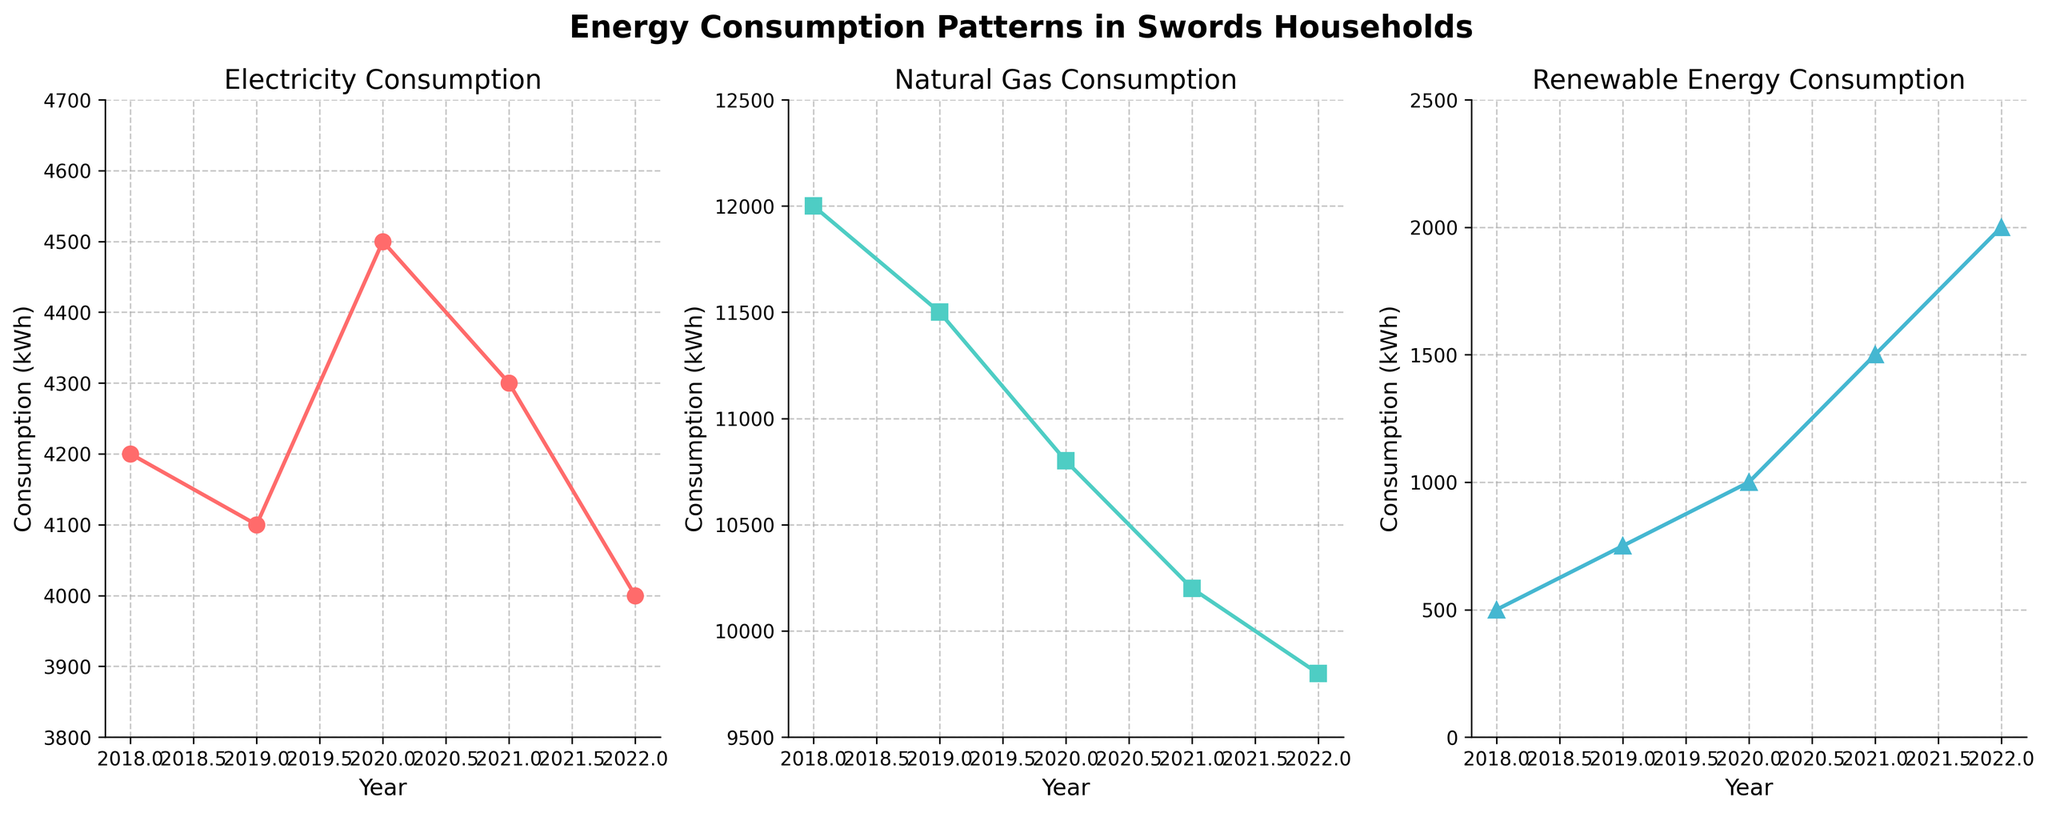What is the title of the figure? The title of the figure is written at the top, centrally aligned, in bold and larger font size.
Answer: Energy Consumption Patterns in Swords Households How many years of data are shown in the plots? The x-axis of each subplot lists the years for which data is provided. By counting the number of years listed, the total number is determined.
Answer: 5 In which year was the electricity consumption highest? The plot for 'Electricity Consumption' shows a peak in the curve. The y-axis value corresponding to the peak is read against the year on the x-axis.
Answer: 2020 What is the trend of renewable energy consumption from 2018 to 2022? The plot for 'Renewable Energy Consumption' shows a clear upward trend. Observing the points from left to right, the values increase each year.
Answer: Increasing How much did natural gas consumption decrease from 2018 to 2022? The 'Natural Gas Consumption' plot shows the values for 2018 and 2022. Subtract the 2022 value from the 2018 value to find the decrease.
Answer: 2200 kWh Which energy source experienced the most significant decrease from 2018 to 2022? By comparing the values for each energy source in 2018 and 2022 across all three plots, calculate the decrease and identify the largest one.
Answer: Natural Gas What was the average electricity consumption over the given years? Add the electricity consumption values for all years and divide by the number of years.
Answer: 4220 kWh Was there any year where renewable energy consumption doubled compared to the previous year? Check the 'Renewable Energy Consumption' plot for a significant jump, particularly looking at the difference from one year to the next.
Answer: Yes, from 2020 to 2021 Is there any data point in the 'Natural Gas Consumption' subplot that is outside the 9500 to 12500 kWh range? By observing the y-axis and the plotted points, verify if any points lie outside this specified range.
Answer: No Which energy source shows the most stability in its consumption over the years? Compare the year-to-year variations (fluctuations) in all three plots to see which one has the smallest changes in consumption.
Answer: Electricity 